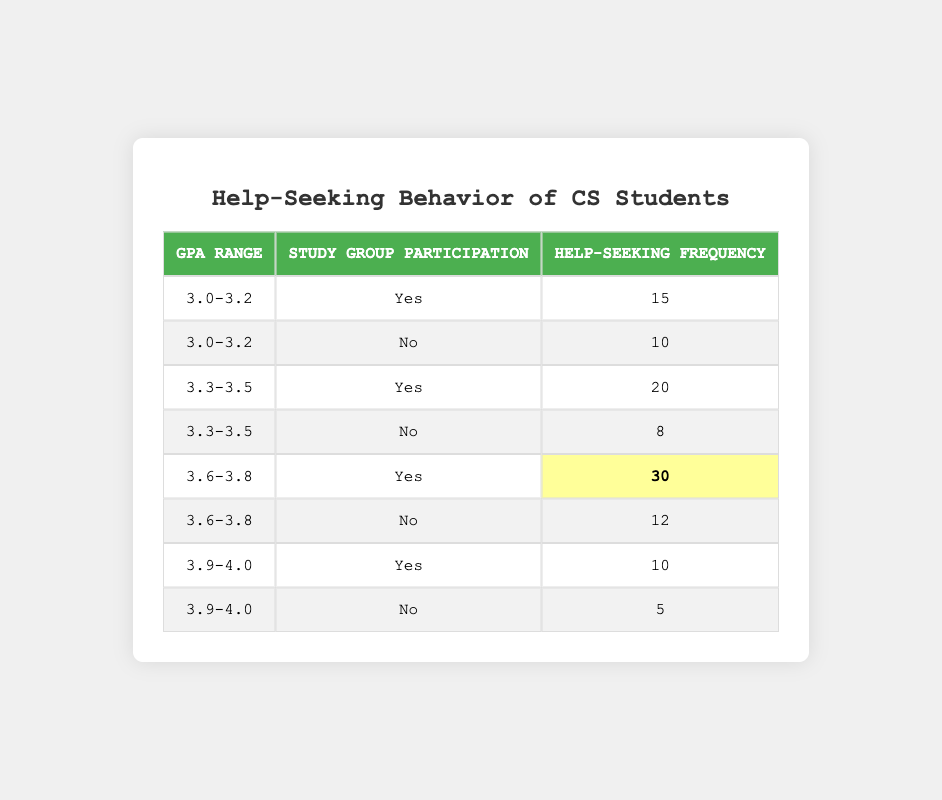What is the help-seeking frequency for students with a GPA of 3.0-3.2 who participate in study groups? The table shows that for students with a GPA of 3.0-3.2 who participate in study groups, the help-seeking frequency is 15.
Answer: 15 How many students with a GPA of 3.3-3.5 do not participate in study groups? According to the table, students with a GPA of 3.3-3.5 who do not participate in study groups have a help-seeking frequency of 8. This means 8 students sought help without participating in study groups.
Answer: 8 What is the total help-seeking frequency for students who participate in study groups? To find the total for students who participate in study groups, sum the values from each GPA range: 15 (3.0-3.2) + 20 (3.3-3.5) + 30 (3.6-3.8) + 10 (3.9-4.0) = 75.
Answer: 75 Do more students with a GPA of 3.6-3.8 seek help compared to those with a GPA of 3.3-3.5 who do not participate in study groups? For students with a GPA of 3.6-3.8 who participate in study groups, the help-seeking frequency is 30. For those with a GPA of 3.3-3.5 who do not participate, it is 8. Since 30 is greater than 8, the answer is yes.
Answer: Yes What is the difference in help-seeking frequency between students with a GPA of 3.0-3.2 who do participate in study groups and those who do not? For students with a GPA of 3.0-3.2, the frequency for those who participate is 15, while those who do not participate is 10. The difference is 15 - 10 = 5.
Answer: 5 